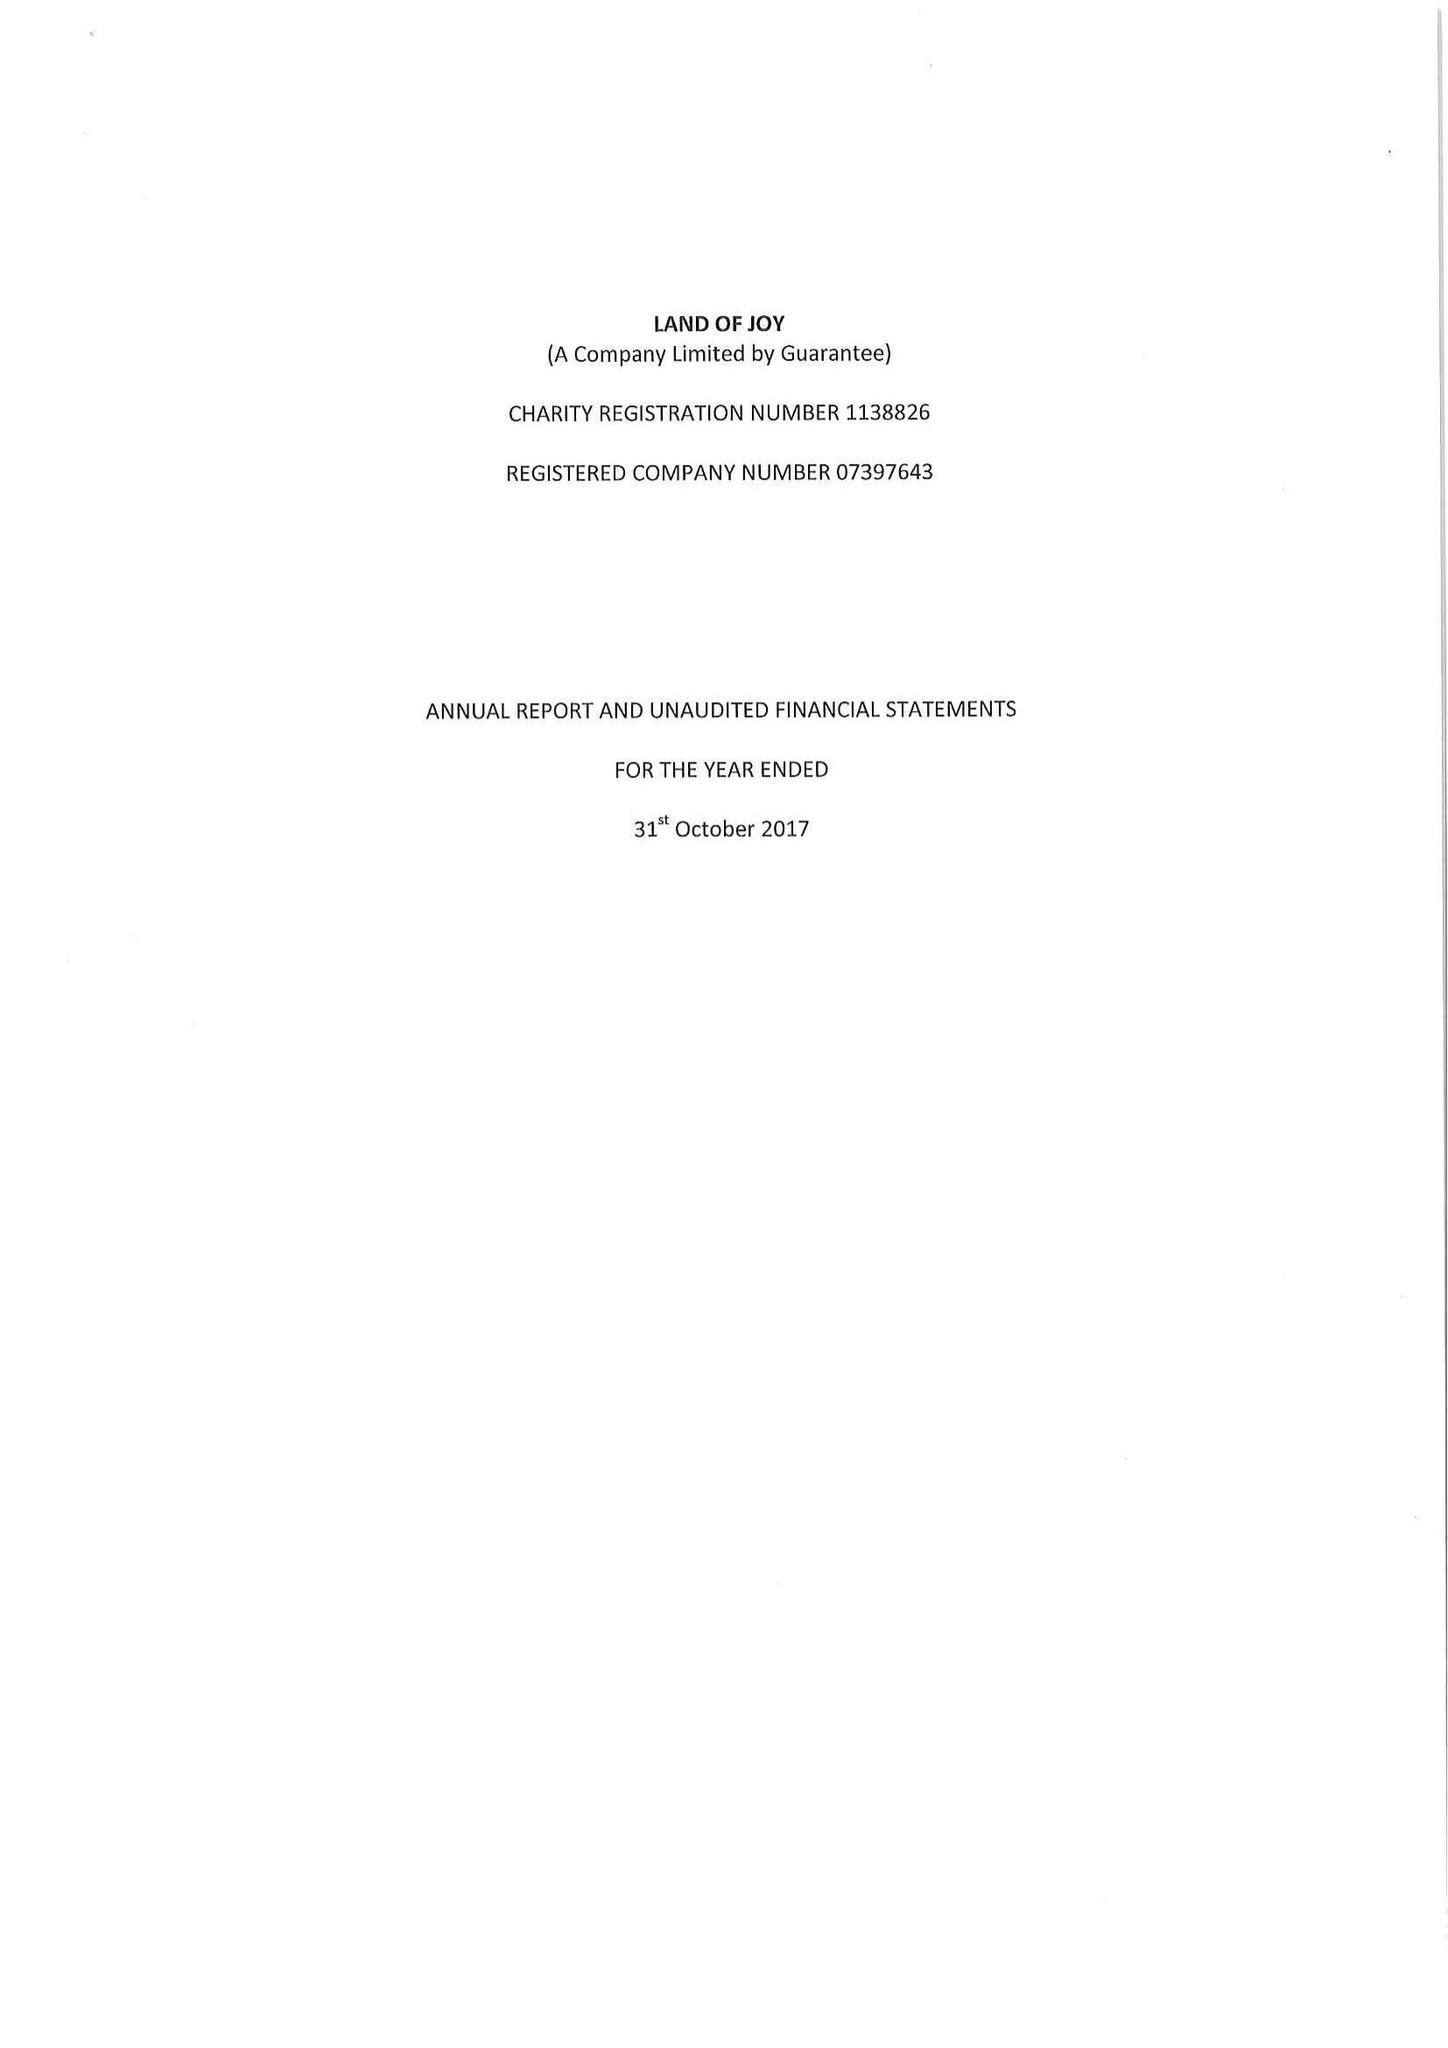What is the value for the charity_number?
Answer the question using a single word or phrase. 1138826 